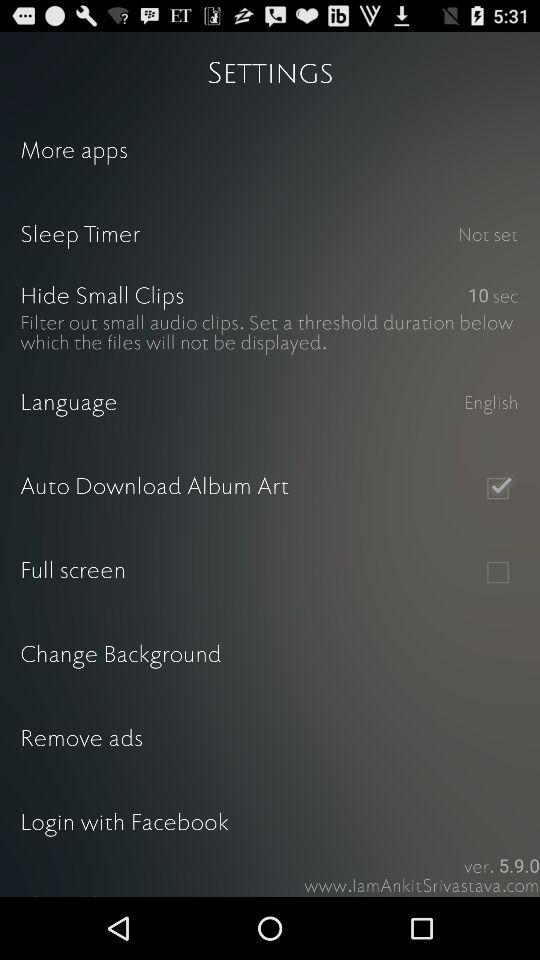Through what application can the user log in? The user can log in through "Facebook". 